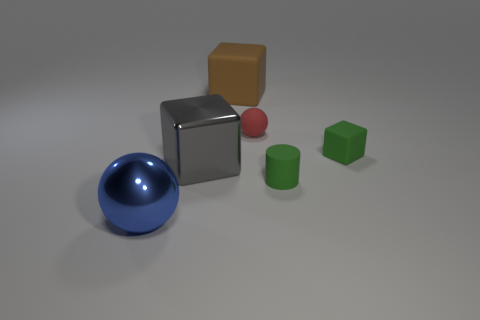Are there any matte blocks of the same color as the cylinder?
Offer a very short reply. Yes. What is the big ball made of?
Offer a very short reply. Metal. What number of objects are either tiny spheres or large metallic spheres?
Ensure brevity in your answer.  2. How big is the green cylinder right of the metallic ball?
Your answer should be compact. Small. What number of other things are the same material as the green cube?
Your answer should be compact. 3. Is there a large sphere that is in front of the cube on the right side of the small rubber sphere?
Offer a terse response. Yes. Are there any other things that are the same shape as the small red matte object?
Offer a terse response. Yes. What is the color of the other large rubber object that is the same shape as the gray object?
Ensure brevity in your answer.  Brown. How big is the red matte ball?
Provide a succinct answer. Small. Are there fewer small rubber objects on the left side of the brown rubber thing than tiny red cylinders?
Provide a short and direct response. No. 